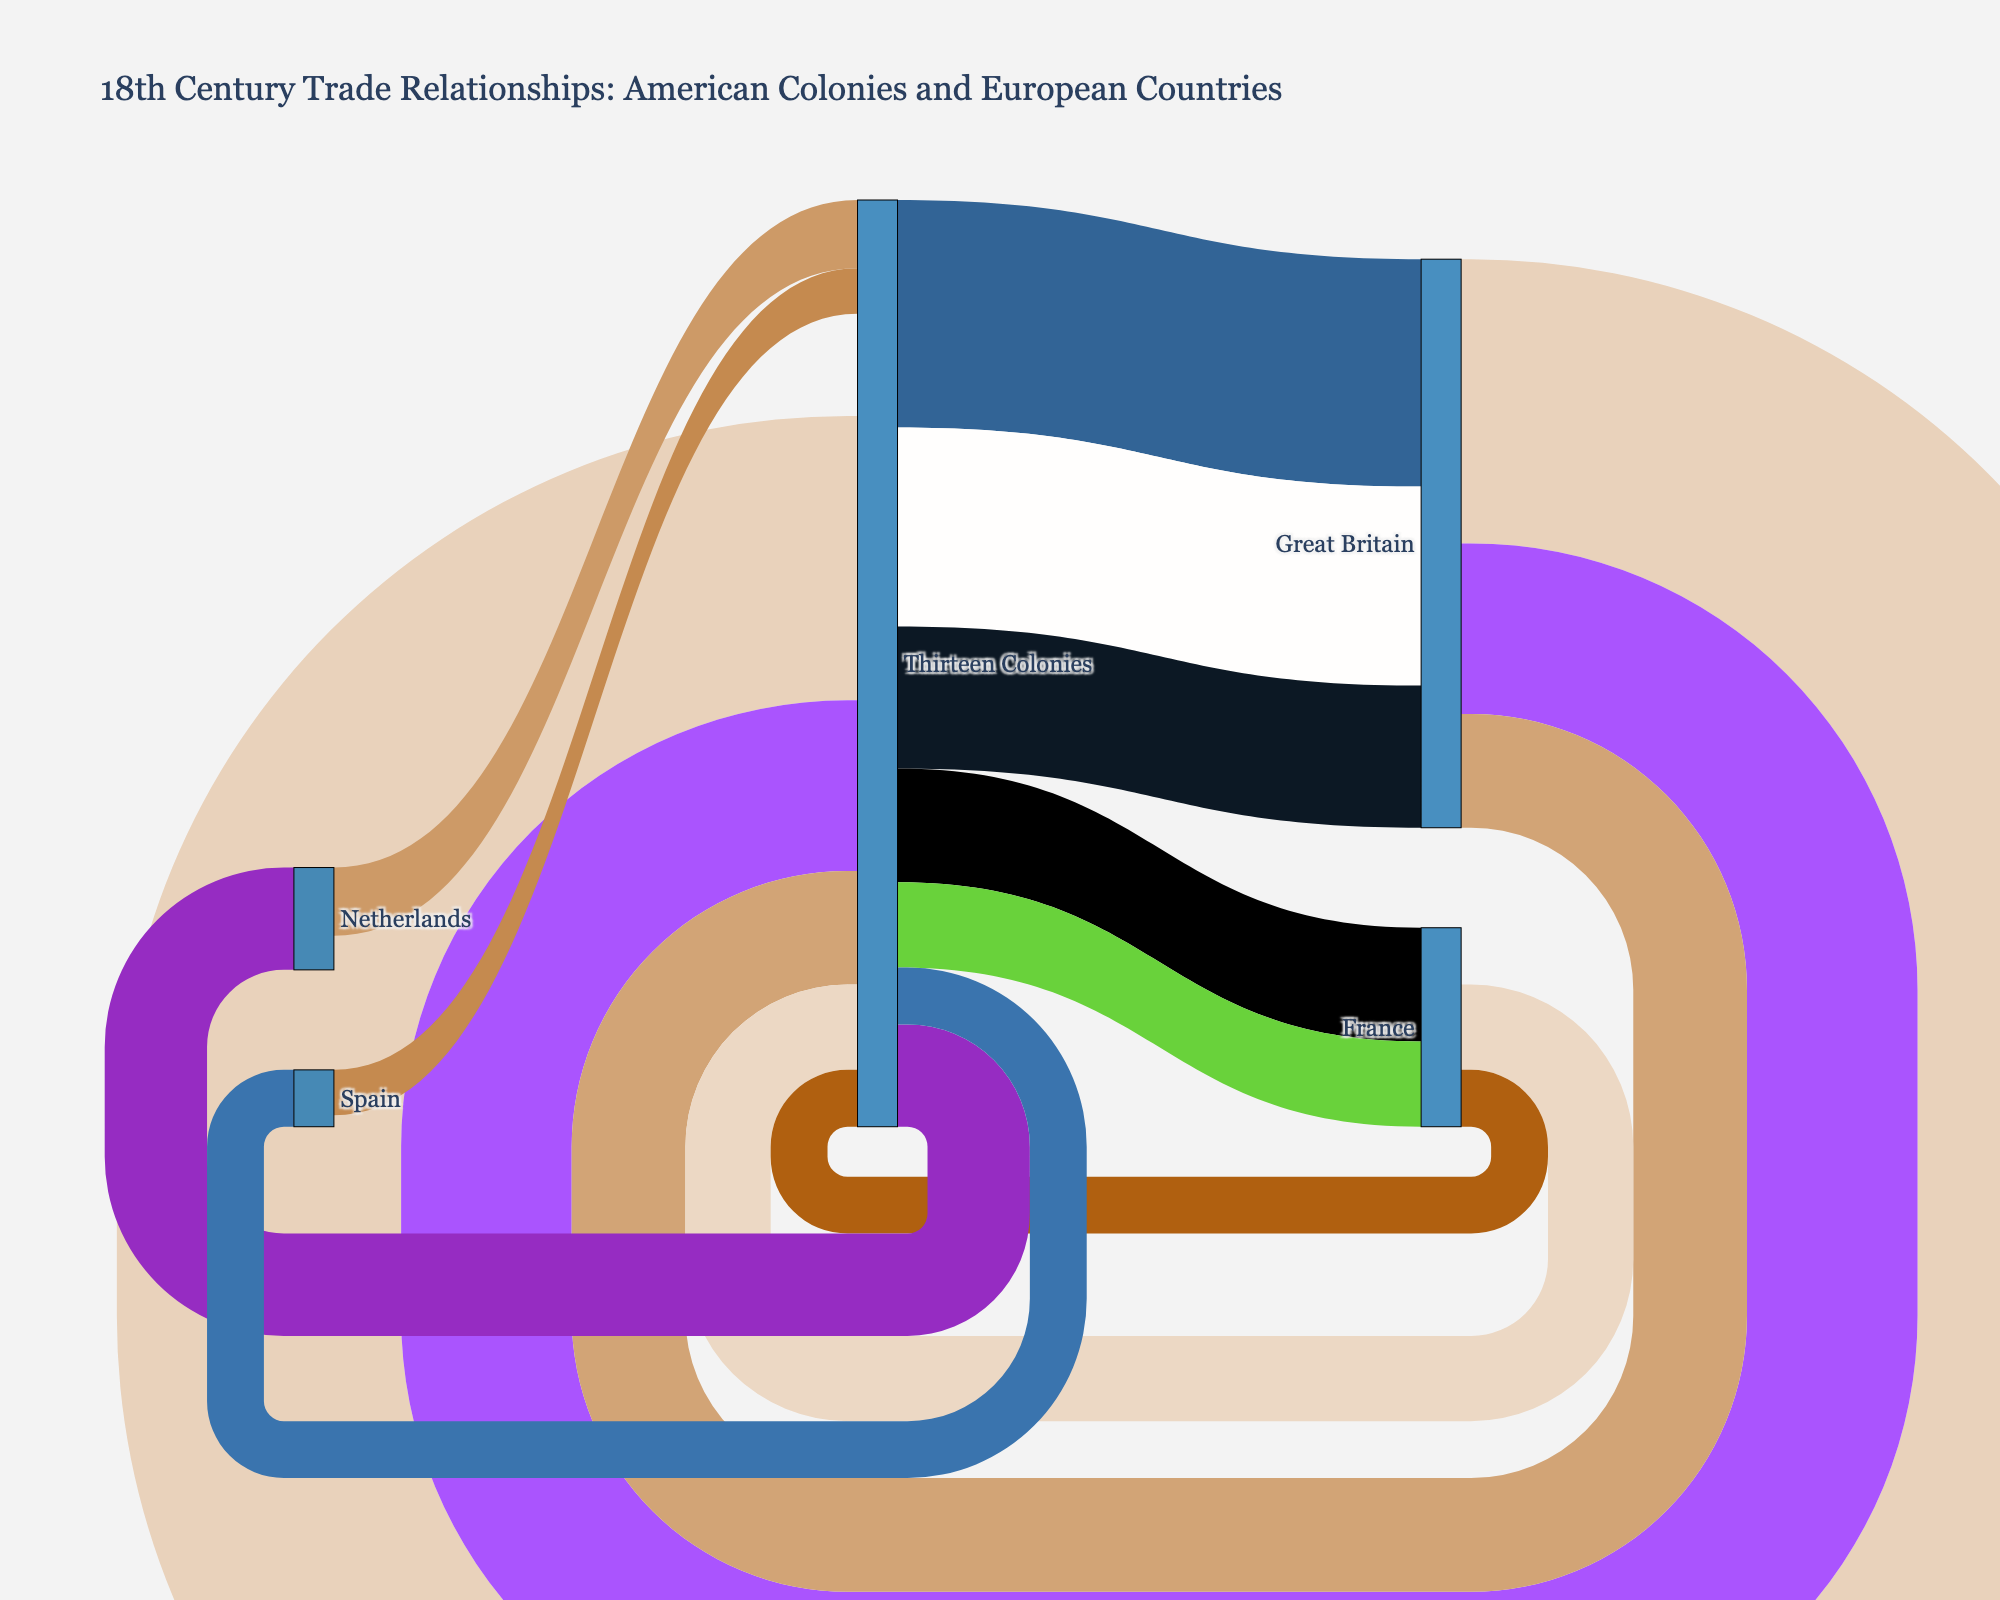What is the title of the Sankey Diagram? The title is displayed at the top of the figure, giving an overview of the content. By looking at the top, we can see that the title is "18th Century Trade Relationships: American Colonies and European Countries".
Answer: 18th Century Trade Relationships: American Colonies and European Countries What color represents the commodity 'Tobacco'? Commodities in the Sankey diagram are represented by different colored flows. By tracing the color of the flow associated with 'Tobacco' from Thirteen Colonies to Great Britain, we can identify its color.
Answer: rgb(220, 75, 56) (assuming the hash function results in this color) Which country exported manufactured goods to the Thirteen Colonies? By examining the sources of flows leading to the Thirteen Colonies, we can identify which country exported manufactured goods by looking at the labels.
Answer: Great Britain What is the combined value of rice and indigo exports from the Thirteen Colonies to France? To calculate the combined value, we need to locate the flows for rice and indigo from Thirteen Colonies to France and sum their values: 2000000 (rice) + 1500000 (indigo) = 3500000.
Answer: 3500000 Which European country imported the least value from the Thirteen Colonies, and what was the commodity? By examining the width of the flows and their values, we can identify the smallest import value from the Thirteen Colonies, which is 1000000 for fish going to Spain.
Answer: Spain, Fish Which commodity had the highest single export value from the Thirteen Colonies, and to which country was it exported? To determine this, we look at the export flows from the Thirteen Colonies and compare their values. The highest value is for Tobacco exported to Great Britain at 4000000.
Answer: Tobacco, Great Britain How many European countries are represented as targets in the trade relationships with the Thirteen Colonies? By counting the unique target nodes (excluding Thirteen Colonies) receiving exports from the Thirteen Colonies, the European countries involved are Great Britain, France, Netherlands, and Spain.
Answer: 4 What is the total value of all commodities imported by the Thirteen Colonies from Great Britain? By summing the values of all commodities imported from Great Britain to the Thirteen Colonies: 5000000 (Manufactured Goods) + 3000000 (Textiles) + 2000000 (Metal Products) = 10000000.
Answer: 10000000 Between Spain and France, which country imported more from the Thirteen Colonies, and what are the total values? To find out, we compare the sum of import values for each country. Spain: 1000000 (Fish). France: 2000000 (Rice) + 1500000 (Indigo) = 3500000. France imported more.
Answer: France, 3500000 Which two commodities exported from the Thirteen Colonies to Great Britain have the closest values? By comparing the values of the commodities exported to Great Britain, Tobacco (4000000), Cotton (3500000), and Timber (2500000), Cotton and Timber have the closest values.
Answer: Cotton and Timber 